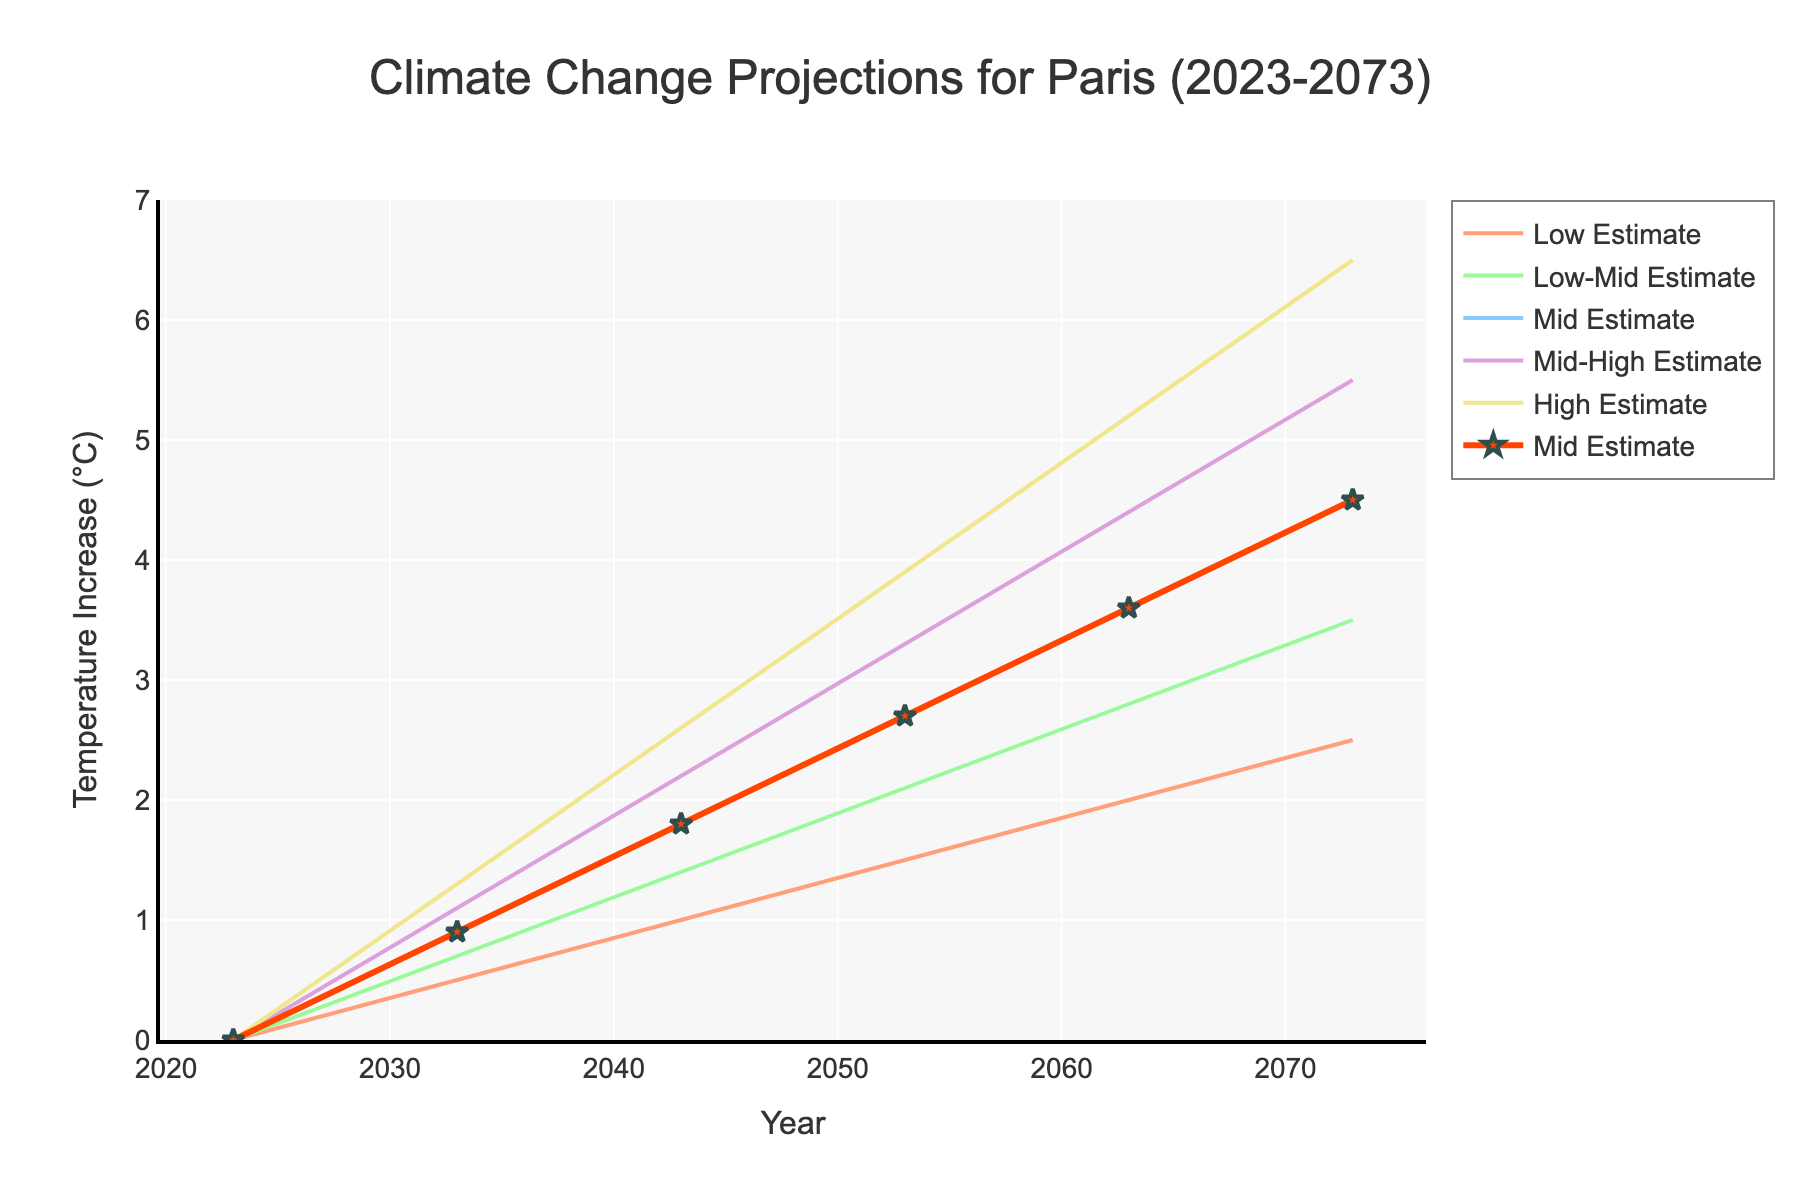what is the title of the figure? The title of the figure is displayed prominently at the top and reads "Climate Change Projections for Paris (2023-2073)".
Answer: Climate Change Projections for Paris (2023-2073) What is the estimated temperature increase in 2073 according to the Mid Estimate? In the figure, the Mid Estimate for 2073 is indicated by both a line and markers. By identifying the point at 2073 on this line, we see the Mid Estimate is 4.5°C.
Answer: 4.5°C Which estimate shows the smallest temperature increase in 2053? The figure contains multiple estimates represented by different colors. The smallest temperature increase for 2053 is shown by the "Low Estimate," which reaches 1.5°C.
Answer: 1.5°C Compare the temperature increase in 2043 between the Low Estimate and High Estimate. The lines for the Low Estimate and High Estimate represent the respective temperature increases. At 2043, the Low Estimate is 1.0°C while the High Estimate is 2.6°C.
Answer: 1.0°C for Low, 2.6°C for High How much more does the temperature increase according to the High Estimate compared to the Low Estimate in 2063? At 2063, the High Estimate is 5.2°C and the Low Estimate is 2.0°C. The difference is calculated by subtracting 2.0°C from 5.2°C.
Answer: 3.2°C What trend can you see in the Mid Estimate from 2023 to 2073? The Mid Estimate line consistently increases from 0°C in 2023 to 4.5°C in 2073, showing a long-term rising trend in temperature.
Answer: Consistent increase If the temperature rises as per the Low-Mid Estimate, what would be the temperature increase by 2053? According to the Low-Mid Estimate line, the temperature increase by 2053 is indicated to be 2.1°C.
Answer: 2.1°C What is the range of temperature increases in 2073 based on the different estimates? The range can be determined by the difference between the High Estimate (6.5°C) and the Low Estimate (2.5°C) for 2073.
Answer: 4°C How does the temperature increase from 2033 to 2043 compare between the Mid Estimate and the Mid-High Estimate? The Mid Estimate increases from 0.9°C in 2033 to 1.8°C in 2043, an increase of 0.9°C. The Mid-High Estimate increases from 1.1°C to 2.2°C, also an increase of 1.1°C.
Answer: Both increase by 0.9°C (Mid Estimate) and 1.1°C (Mid-High Estimate) What is the color of the line representing the Low-Mid Estimate? The line representing the Low-Mid Estimate is colored in light green.
Answer: light green 